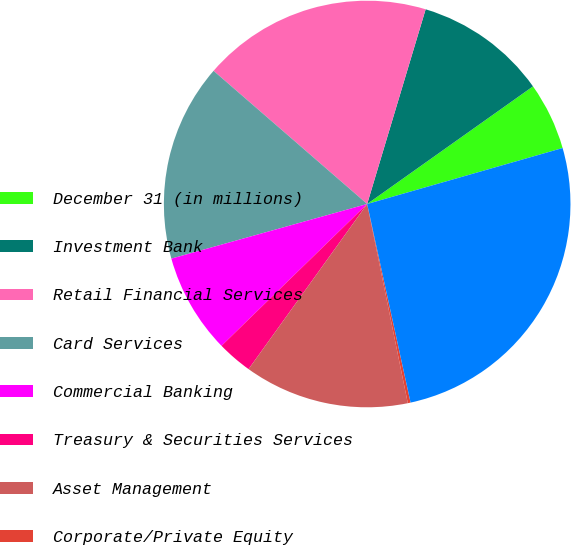Convert chart to OTSL. <chart><loc_0><loc_0><loc_500><loc_500><pie_chart><fcel>December 31 (in millions)<fcel>Investment Bank<fcel>Retail Financial Services<fcel>Card Services<fcel>Commercial Banking<fcel>Treasury & Securities Services<fcel>Asset Management<fcel>Corporate/Private Equity<fcel>Total goodwill<nl><fcel>5.38%<fcel>10.54%<fcel>18.28%<fcel>15.7%<fcel>7.96%<fcel>2.8%<fcel>13.12%<fcel>0.22%<fcel>26.02%<nl></chart> 